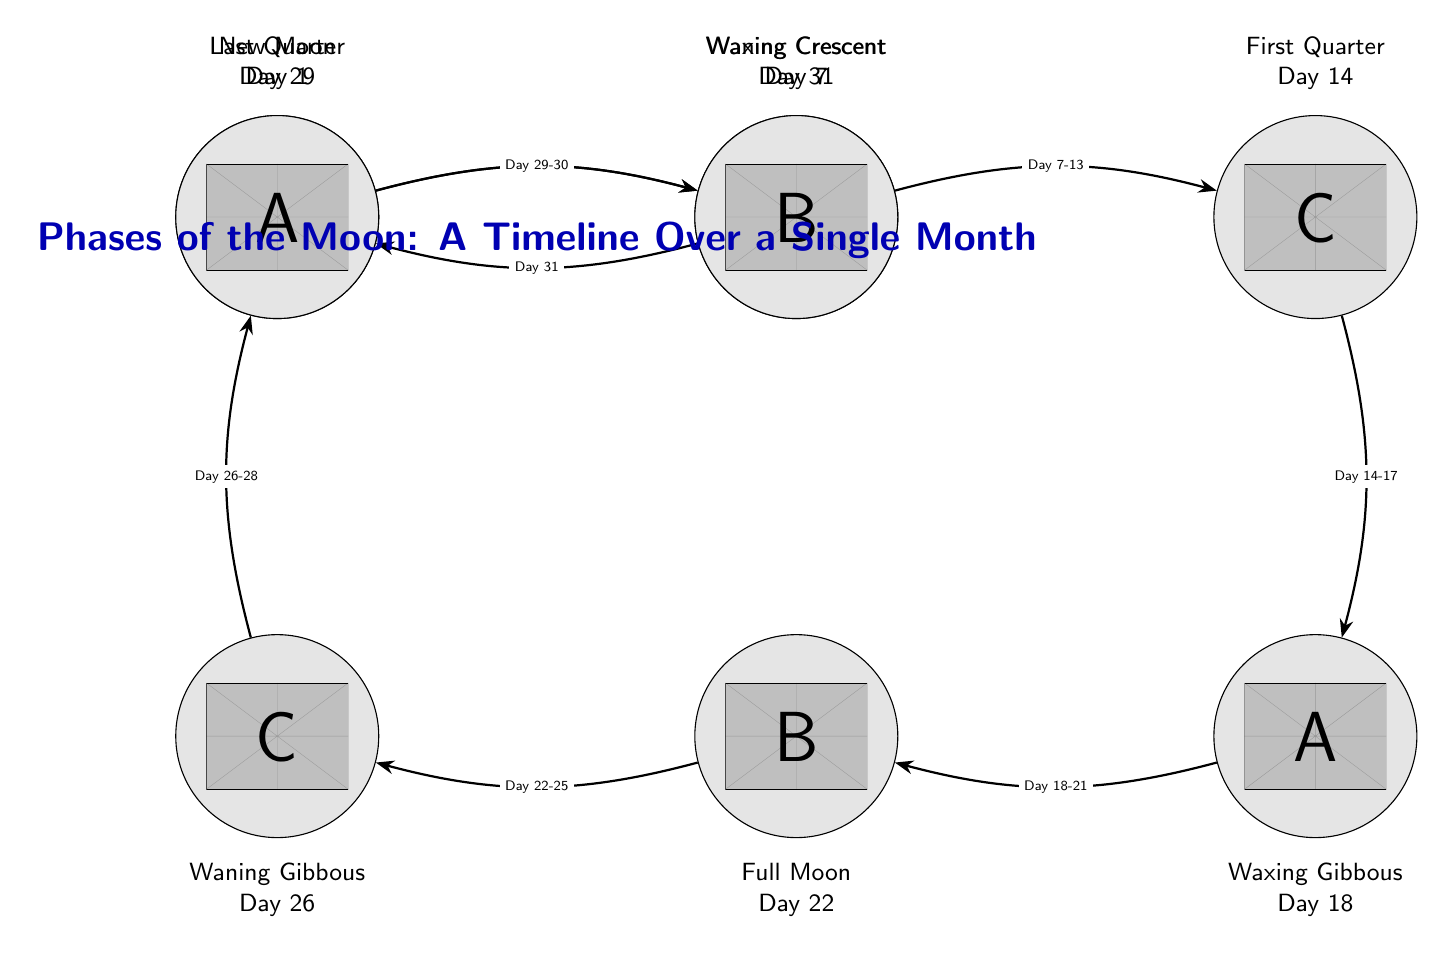What lunar phase occurs on Day 1? In the diagram, the lunar phase labeled "New Moon" is directly above the label for Day 1, indicating that this is the phase during that day.
Answer: New Moon How many lunar phases are shown in the diagram? By counting the distinct nodes labeled with lunar phases from the diagram, there are eight phases depicted: New Moon, Waxing Crescent, First Quarter, Waxing Gibbous, Full Moon, Waning Gibbous, Last Quarter, and Waning Crescent.
Answer: 8 What is the phase on Day 22? The diagram labels the phase "Full Moon" directly above Day 22, indicating that this is the phase occurring on that day.
Answer: Full Moon What is the relationship between the Full Moon and the Waning Gibbous? The arrow connecting the Full Moon to Waning Gibbous indicates the transition from one phase to the next, with the label noting the days from 22 to 25 between them.
Answer: Transition What is the phase occurring from Day 14 to Day 17? The arrow between the First Quarter and Waxing Gibbous specifies the time frame of Day 14 to Day 17 for this transition, affirming that Waxing Gibbous is the phase in that range.
Answer: Waxing Gibbous On which day does the Last Quarter occur? The label for Last Quarter is shown directly under "Day 29," indicating that this phase takes place on this specific day of the month.
Answer: Day 29 How do the phases progress after the Full Moon? Following the Full Moon, the diagram indicates that the next phase is Waning Gibbous (Day 22 to 25), followed by Last Quarter (Day 29 to 30), and finally Waning Crescent (Day 31), thus showing the order of phases that follow it.
Answer: Waning Gibbous, Last Quarter, Waning Crescent Which lunar phase lasts from Day 1 to Day 6? The arrow leading from New Moon to Waxing Crescent points out that this phase spans those specific days, confirming the phase in question.
Answer: Waxing Crescent What is unique about the timeline shown for the lunar phases? The diagram uniquely illustrates the progression of lunar phases over a single month, essentially showing each phase's timing within that timeframe as distinct steps connected by arrows.
Answer: Single month progression 